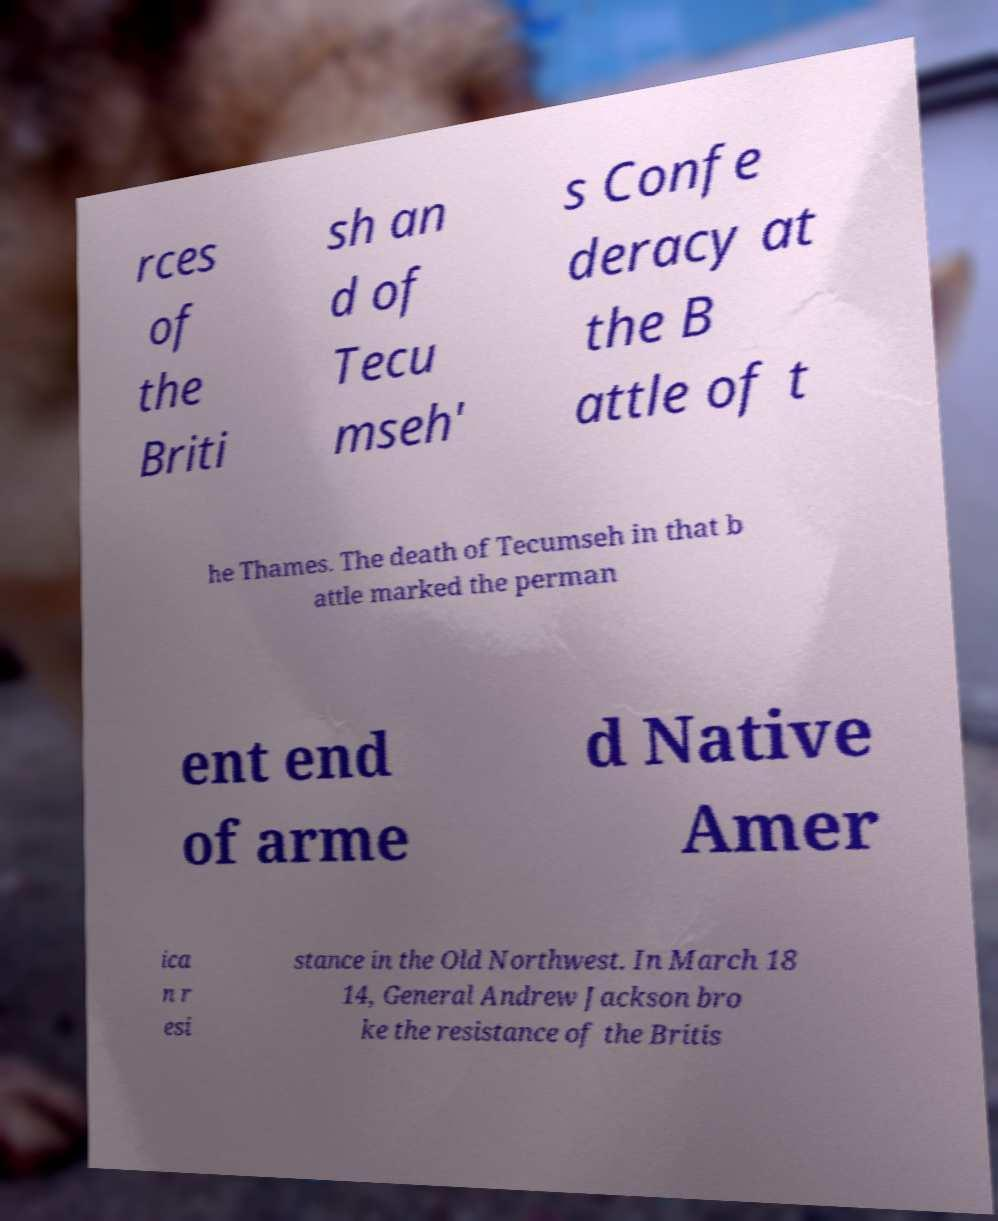Please identify and transcribe the text found in this image. rces of the Briti sh an d of Tecu mseh' s Confe deracy at the B attle of t he Thames. The death of Tecumseh in that b attle marked the perman ent end of arme d Native Amer ica n r esi stance in the Old Northwest. In March 18 14, General Andrew Jackson bro ke the resistance of the Britis 